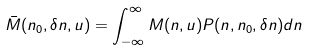Convert formula to latex. <formula><loc_0><loc_0><loc_500><loc_500>\bar { M } ( n _ { 0 } , \delta n , u ) = \int _ { - \infty } ^ { \infty } M ( n , u ) P ( n , n _ { 0 } , \delta n ) d n</formula> 